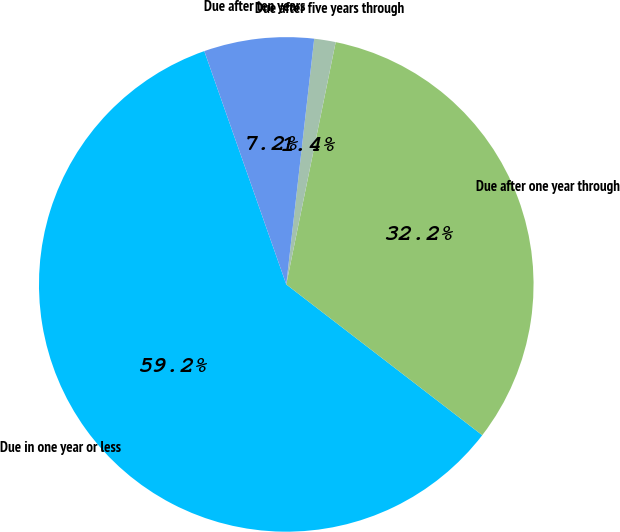Convert chart to OTSL. <chart><loc_0><loc_0><loc_500><loc_500><pie_chart><fcel>Due in one year or less<fcel>Due after one year through<fcel>Due after five years through<fcel>Due after ten years<nl><fcel>59.18%<fcel>32.23%<fcel>1.4%<fcel>7.18%<nl></chart> 